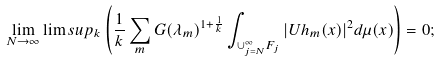Convert formula to latex. <formula><loc_0><loc_0><loc_500><loc_500>\lim _ { N \to \infty } \lim s u p _ { k } \left ( \frac { 1 } { k } \sum _ { m } G ( \lambda _ { m } ) ^ { 1 + \frac { 1 } { k } } \int _ { \cup _ { j = N } ^ { \infty } F _ { j } } | U h _ { m } ( x ) | ^ { 2 } d \mu ( x ) \right ) = 0 ;</formula> 